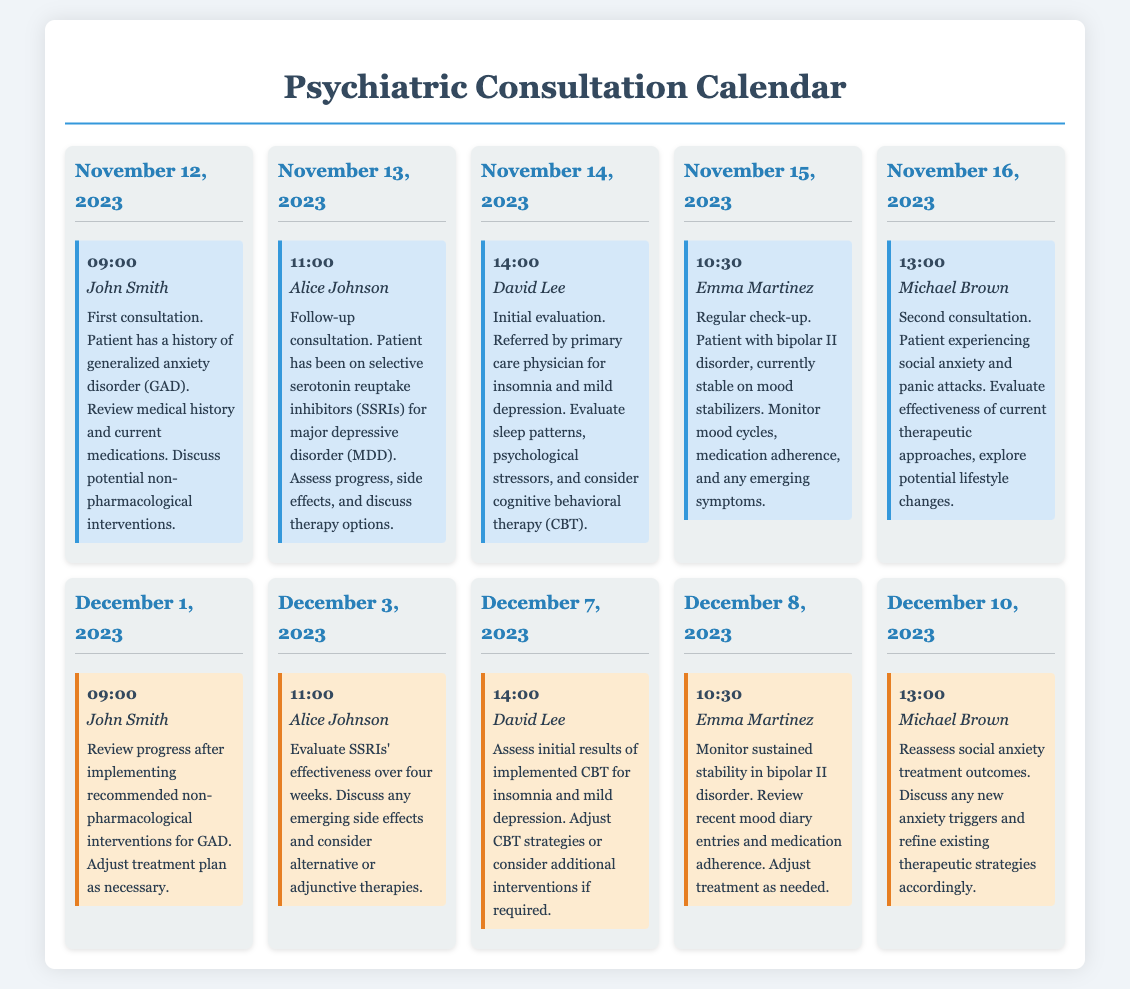What is the date of John's first consultation? The document states that John's first consultation is scheduled for November 12, 2023.
Answer: November 12, 2023 What is the time of Alice Johnson's follow-up appointment? The follow-up appointment for Alice Johnson is at 11:00 on December 3, 2023.
Answer: 11:00 What diagnosis does David Lee have? David Lee is referred for insomnia and mild depression as mentioned in the initial evaluation details.
Answer: Insomnia and mild depression How many patients have follow-up appointments in December? The document lists five patients with follow-up appointments in December (John Smith, Alice Johnson, David Lee, Emma Martinez, Michael Brown).
Answer: Five Which therapeutic option is discussed for John Smith during his first consultation? The details mention the discussion of potential non-pharmacological interventions for John Smith's Generalized Anxiety Disorder (GAD).
Answer: Non-pharmacological interventions What is the focus of the follow-up consultation on December 8, 2023? The follow-up on December 8, 2023, focuses on monitoring sustained stability in bipolar II disorder for Emma Martinez.
Answer: Monitoring sustained stability Which patient has a regular check-up? The document indicates that Emma Martinez has a regular check-up scheduled on November 15, 2023.
Answer: Emma Martinez How long has Alice Johnson been on SSRIs before her follow-up appointment? Alice Johnson has been on SSRIs for four weeks before her follow-up consultation on December 3, 2023.
Answer: Four weeks 